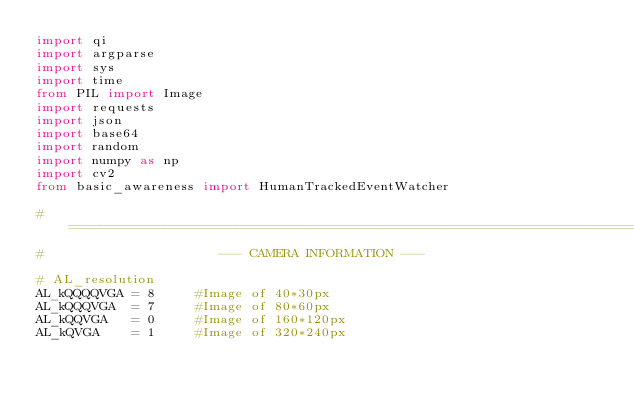<code> <loc_0><loc_0><loc_500><loc_500><_Python_>import qi
import argparse
import sys
import time
from PIL import Image
import requests
import json
import base64
import random
import numpy as np
import cv2
from basic_awareness import HumanTrackedEventWatcher

# ==============================================================================
#                      --- CAMERA INFORMATION ---

# AL_resolution
AL_kQQQQVGA = 8     #Image of 40*30px
AL_kQQQVGA  = 7     #Image of 80*60px
AL_kQQVGA   = 0     #Image of 160*120px
AL_kQVGA    = 1     #Image of 320*240px</code> 